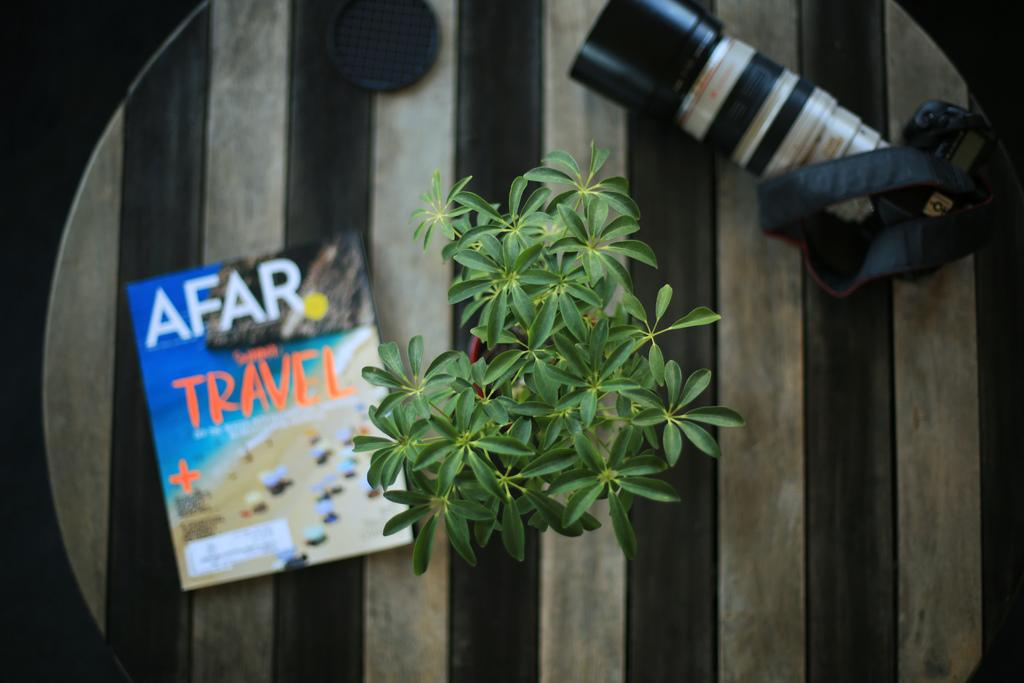What is one of the objects visible in the image? There is a book in the image. What other object can be seen in the image? There is a camera in the image. What else is present in the image? There is a plant pot in the image. On what surface are the objects placed? The objects are on a wooden table. How many jellyfish are swimming in the plant pot in the image? There are no jellyfish present in the image, and they cannot swim in a plant pot. 